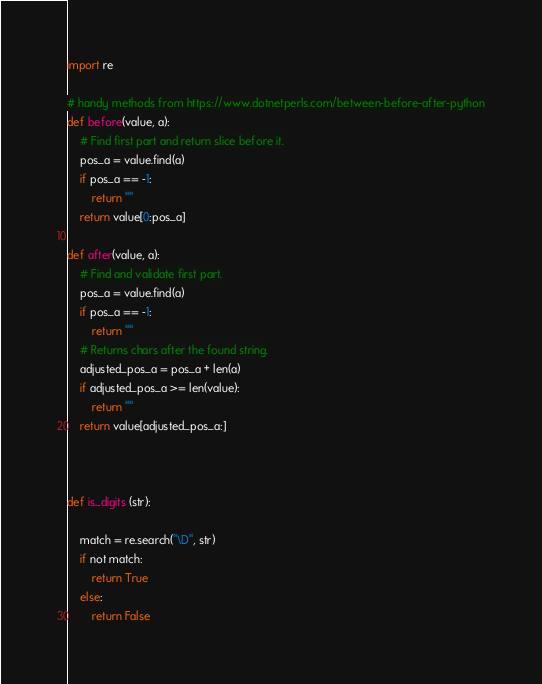Convert code to text. <code><loc_0><loc_0><loc_500><loc_500><_Python_>import re

# handy methods from https://www.dotnetperls.com/between-before-after-python
def before(value, a):
    # Find first part and return slice before it.
    pos_a = value.find(a)
    if pos_a == -1: 
        return ""
    return value[0:pos_a]
    
def after(value, a):
    # Find and validate first part.
    pos_a = value.find(a)
    if pos_a == -1: 
        return ""
    # Returns chars after the found string.
    adjusted_pos_a = pos_a + len(a)
    if adjusted_pos_a >= len(value): 
        return ""
    return value[adjusted_pos_a:]



def is_digits (str):

    match = re.search("\D", str)
    if not match:
        return True
    else:
        return False</code> 